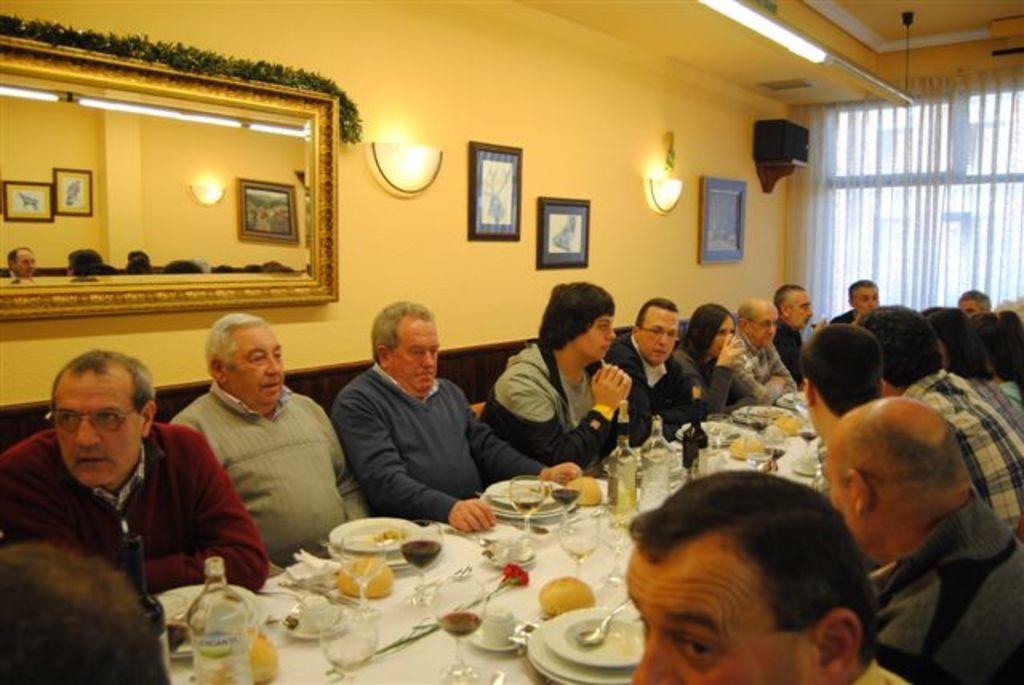Could you give a brief overview of what you see in this image? people are seated on the chairs around the table. on the table there are glasses, plates, spoon and food. behind them there is a mirror, photo frame and light. 